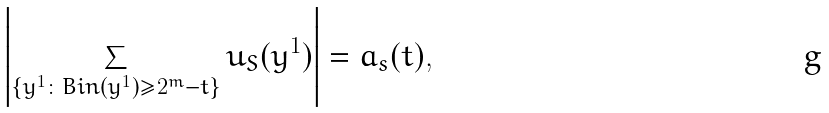<formula> <loc_0><loc_0><loc_500><loc_500>\left | \sum _ { \{ y ^ { 1 } \colon B i n ( y ^ { 1 } ) \geq 2 ^ { m } - t \} } u _ { S } ( y ^ { 1 } ) \right | = a _ { s } ( t ) ,</formula> 